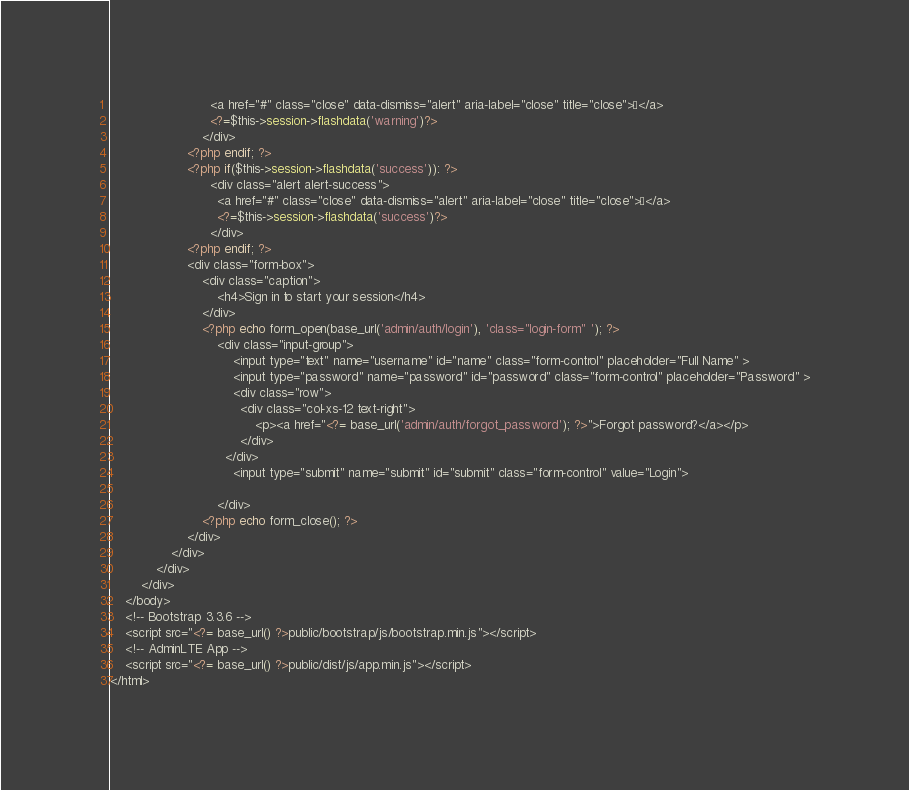<code> <loc_0><loc_0><loc_500><loc_500><_PHP_>                          <a href="#" class="close" data-dismiss="alert" aria-label="close" title="close">×</a>
                          <?=$this->session->flashdata('warning')?>
                        </div>
                    <?php endif; ?>
                    <?php if($this->session->flashdata('success')): ?>
                          <div class="alert alert-success">
                            <a href="#" class="close" data-dismiss="alert" aria-label="close" title="close">×</a>
                            <?=$this->session->flashdata('success')?>
                          </div>
                    <?php endif; ?>
                    <div class="form-box">
                        <div class="caption">
                            <h4>Sign in to start your session</h4>
                        </div>
                        <?php echo form_open(base_url('admin/auth/login'), 'class="login-form" '); ?>
                            <div class="input-group">
                                <input type="text" name="username" id="name" class="form-control" placeholder="Full Name" >
                                <input type="password" name="password" id="password" class="form-control" placeholder="Password" >
                                <div class="row">
                                  <div class="col-xs-12 text-right">
                                      <p><a href="<?= base_url('admin/auth/forgot_password'); ?>">Forgot password?</a></p>
                                  </div>
                              </div>
                                <input type="submit" name="submit" id="submit" class="form-control" value="Login">
                
                            </div>
                        <?php echo form_close(); ?>
                    </div>
                </div>
            </div>
        </div>
    </body>
    <!-- Bootstrap 3.3.6 -->
    <script src="<?= base_url() ?>public/bootstrap/js/bootstrap.min.js"></script>
    <!-- AdminLTE App -->
    <script src="<?= base_url() ?>public/dist/js/app.min.js"></script>
</html></code> 